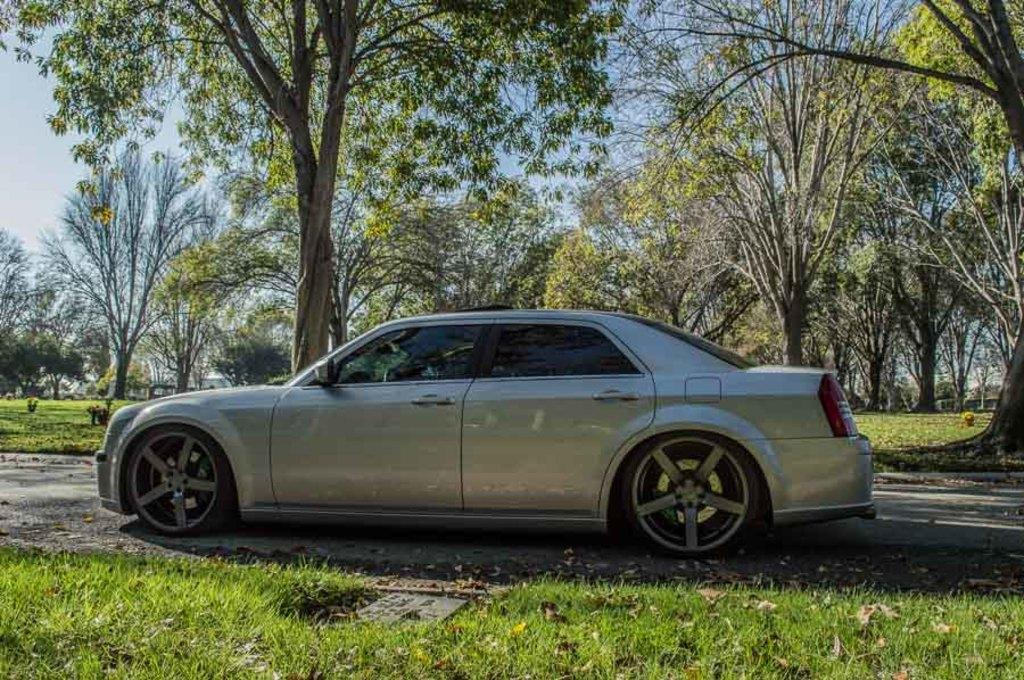What type of vehicle is in the image? There is a grey car in the image. Where is the car located in relation to the grass? The car is parked near grass in the image. What can be seen in the background of the image? There are many trees and plants in the background of the image. What is visible at the top of the image? The sky is visible at the top of the image. What can be observed in the sky? Clouds are present in the sky. How many dogs are sitting on the car in the image? There are no dogs present in the image; it features a grey car parked near grass with a background of trees and plants. 